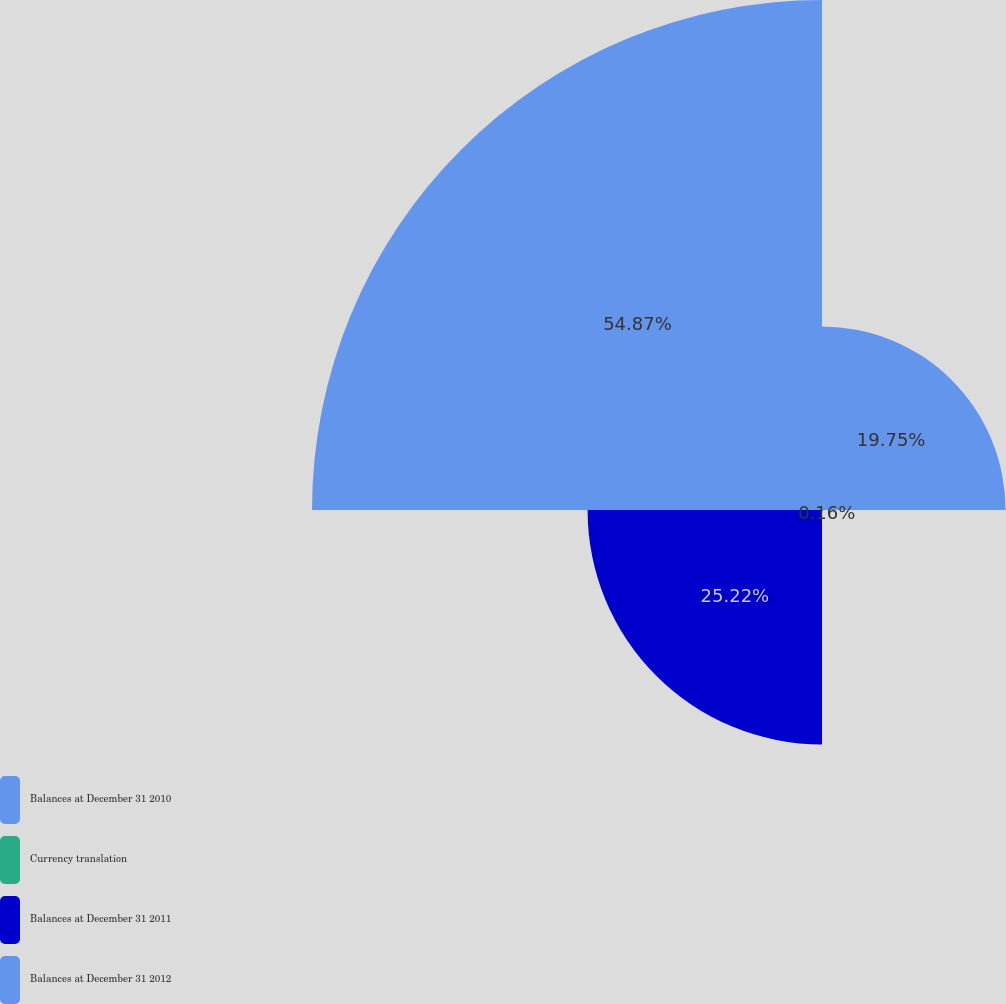Convert chart. <chart><loc_0><loc_0><loc_500><loc_500><pie_chart><fcel>Balances at December 31 2010<fcel>Currency translation<fcel>Balances at December 31 2011<fcel>Balances at December 31 2012<nl><fcel>19.75%<fcel>0.16%<fcel>25.22%<fcel>54.87%<nl></chart> 